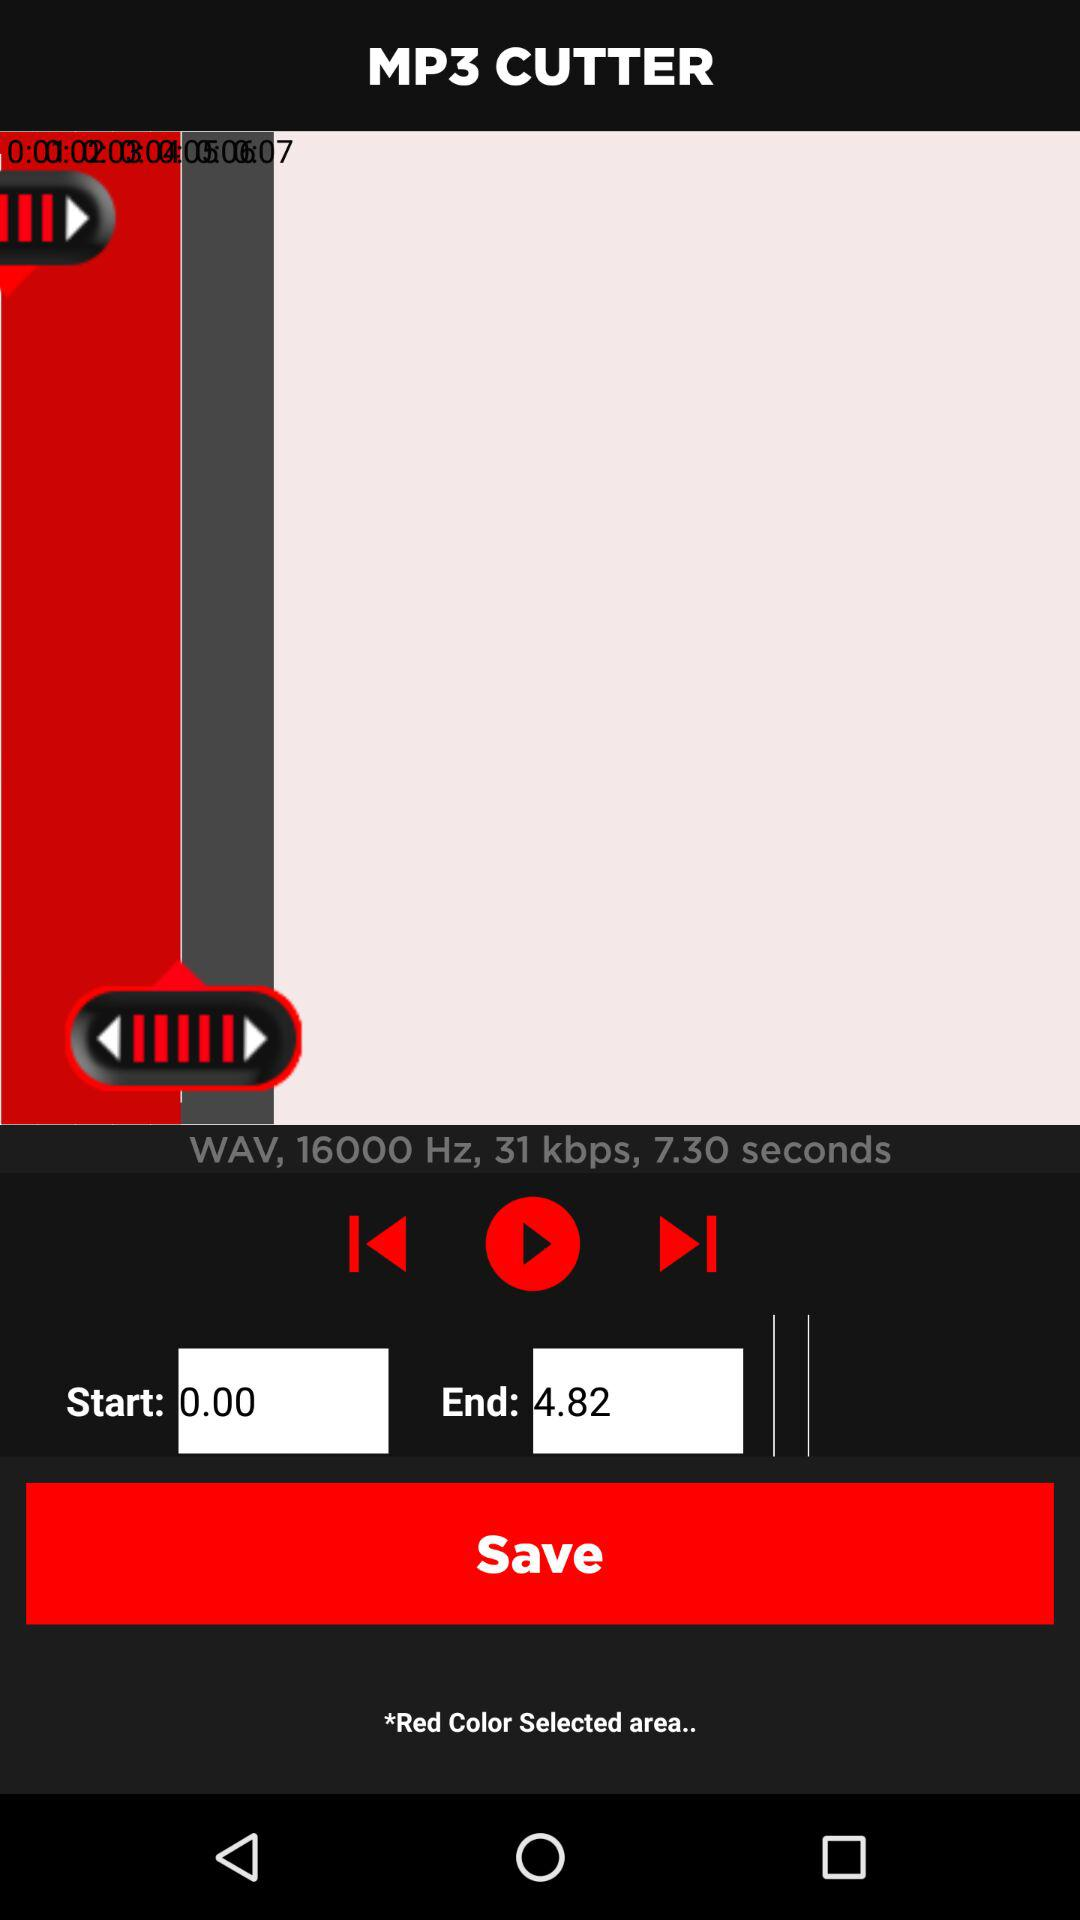What is the end time? The end time is 4.82. 